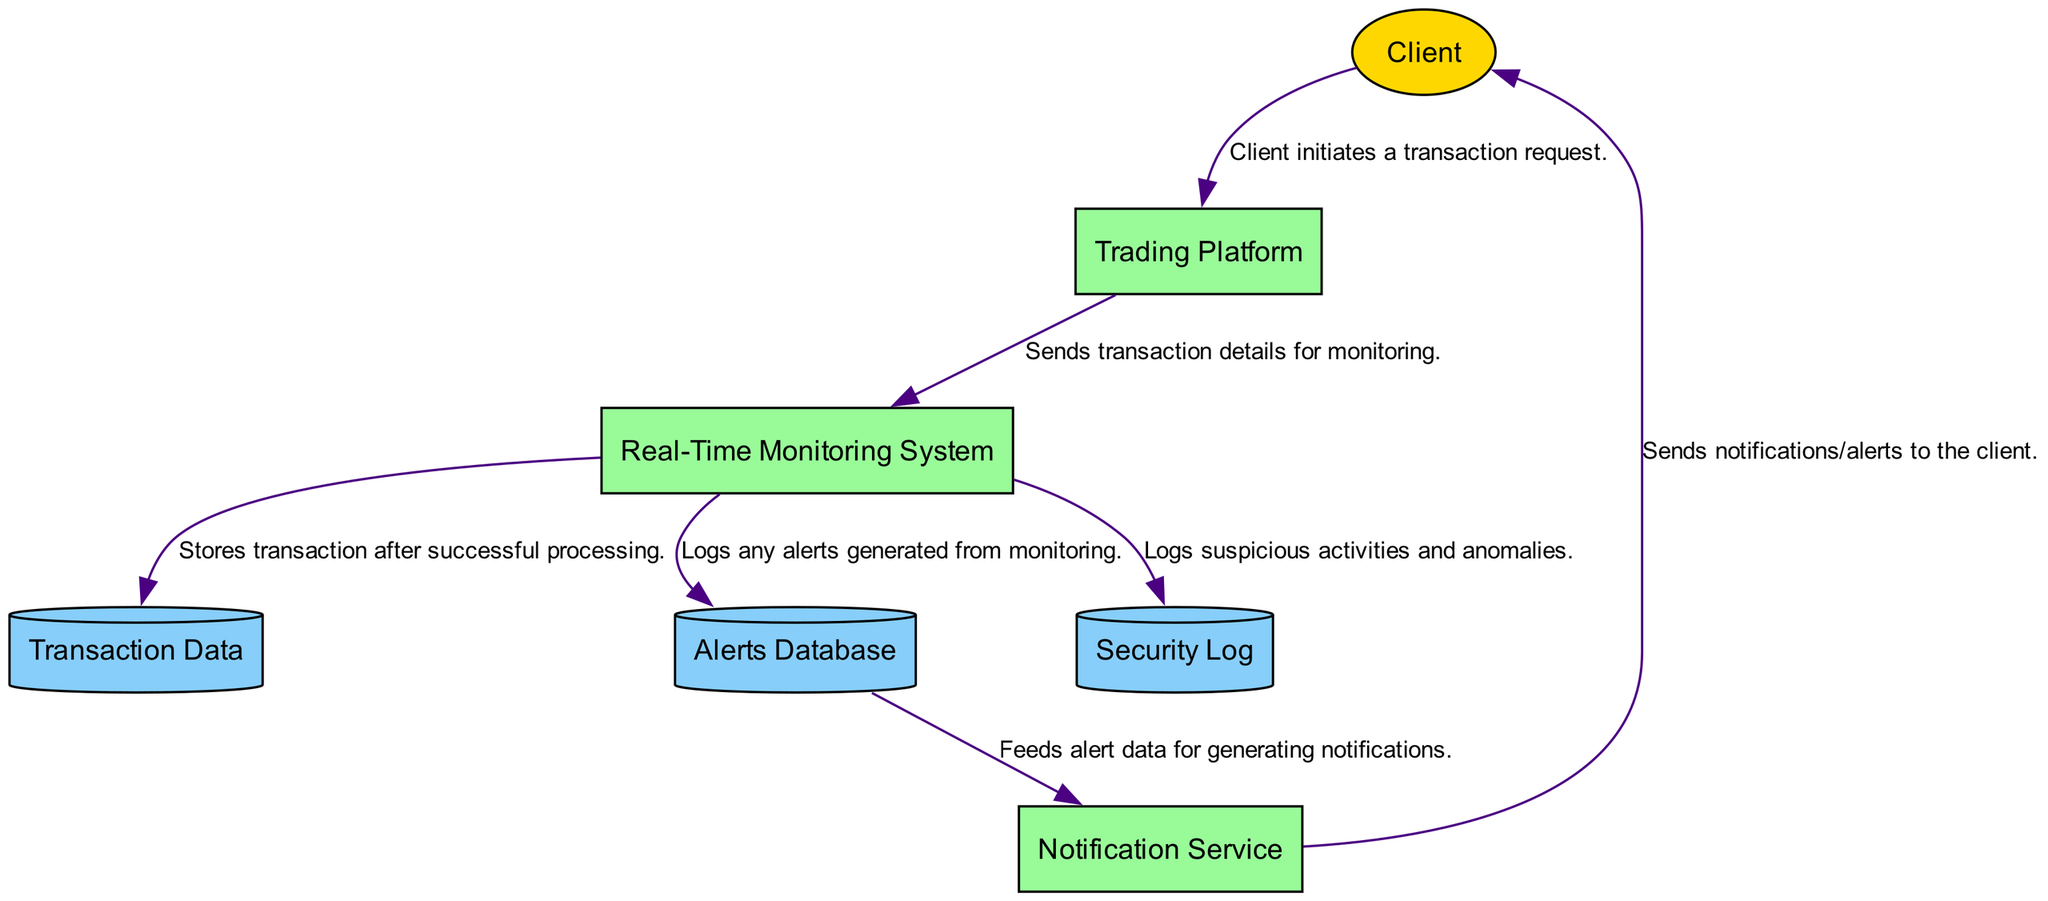What is the external entity that initiates transactions? The diagram includes the "Client" as an external entity. It is represented as the source for the transaction initiation flow towards the "Trading Platform".
Answer: Client How many data stores are present in the diagram? The diagram shows three data stores: "Transaction Data", "Alerts Database", and "Security Log". Thus, there are three distinct records of data represented.
Answer: 3 What is the process that sends transaction details for monitoring? The "Trading Platform" is the process responsible for sending the transaction details to the "Real-Time Monitoring System" for further analysis and monitoring.
Answer: Trading Platform Which entity sends alerts to clients? The "Notification Service" is responsible for sending alerts to clients based on triggers from the monitoring system, making it the key entity for communication with clients.
Answer: Notification Service What is the relationship between the "Real-Time Monitoring System" and "Alerts Database"? The "Real-Time Monitoring System" feeds alert data to the "Alerts Database", which is a process that logs any alerts generated from monitoring actions. This relationship shows the flow of alert information for future analysis.
Answer: Logs alerts What action does the "Real-Time Monitoring System" take when it detects suspicious activities? When suspicious activities are detected, the "Real-Time Monitoring System" logs these events in the "Security Log". This is crucial for maintaining a record of any security-related incidents.
Answer: Logs suspicious activities How many processes are there in the diagram? The diagram contains four processes: "Trading Platform", "Real-Time Monitoring System", "Notification Service", and the previously mentioned "Real-Time Monitoring System". Therefore, there are four distinct processes facilitating transaction and alert handling.
Answer: 4 What data flow does the "Alerts Database" provide to the "Notification Service"? The "Alerts Database" feeds alert data into the "Notification Service" to generate notifications for clients, indicating a directional flow of information from data storage to processing for alerts.
Answer: Feeds alert data What happens to transaction details after successful processing in the "Real-Time Monitoring System"? After successful processing, the "Real-Time Monitoring System" stores the transaction details in the "Transaction Data" data store, ensuring a record of completed transactions.
Answer: Stores transaction 